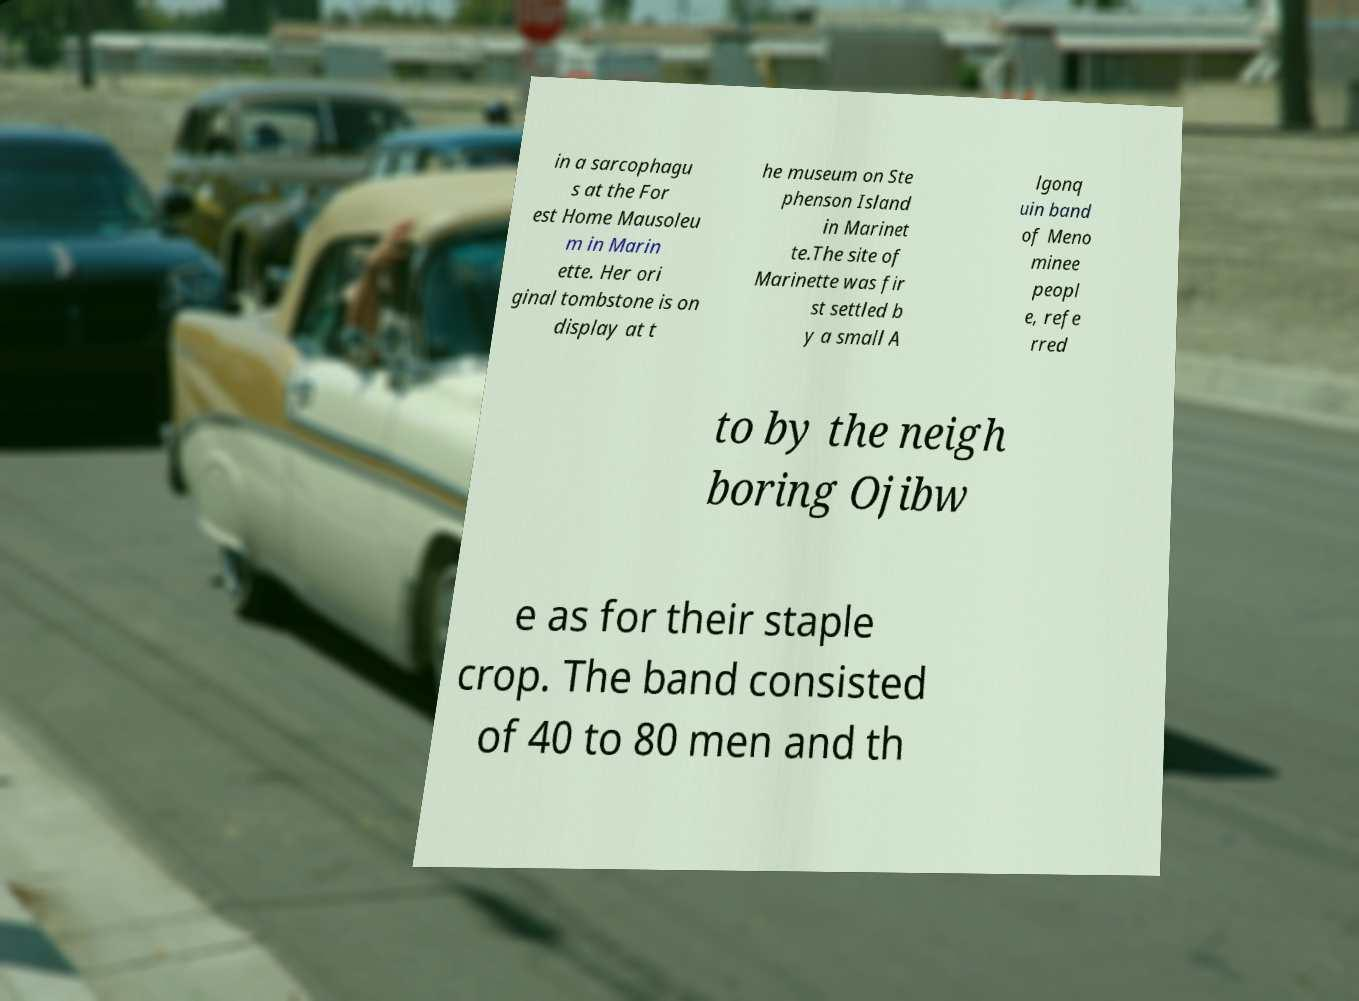There's text embedded in this image that I need extracted. Can you transcribe it verbatim? in a sarcophagu s at the For est Home Mausoleu m in Marin ette. Her ori ginal tombstone is on display at t he museum on Ste phenson Island in Marinet te.The site of Marinette was fir st settled b y a small A lgonq uin band of Meno minee peopl e, refe rred to by the neigh boring Ojibw e as for their staple crop. The band consisted of 40 to 80 men and th 